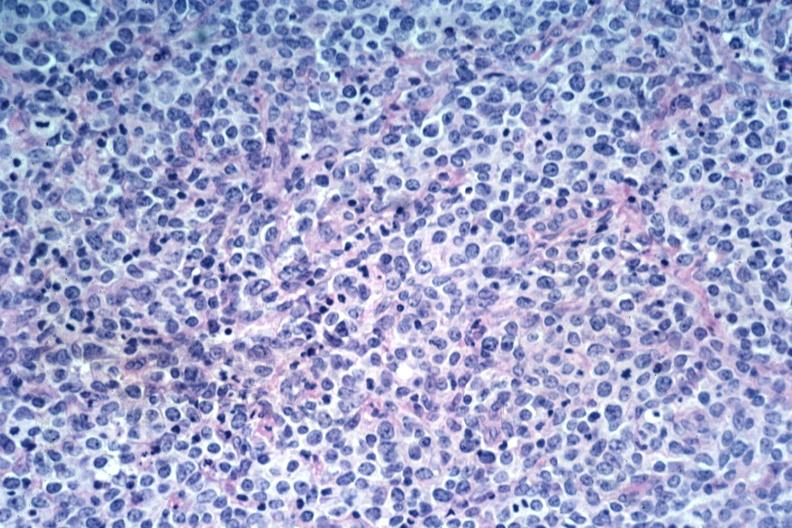does this image show large cell lymphoma?
Answer the question using a single word or phrase. Yes 